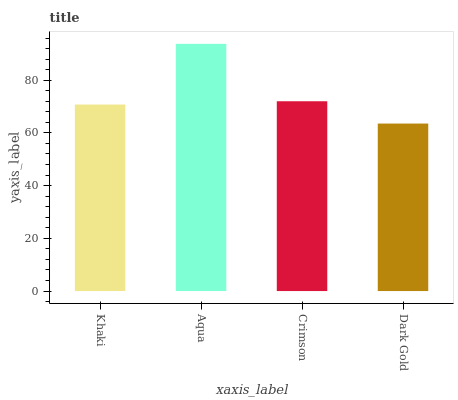Is Dark Gold the minimum?
Answer yes or no. Yes. Is Aqua the maximum?
Answer yes or no. Yes. Is Crimson the minimum?
Answer yes or no. No. Is Crimson the maximum?
Answer yes or no. No. Is Aqua greater than Crimson?
Answer yes or no. Yes. Is Crimson less than Aqua?
Answer yes or no. Yes. Is Crimson greater than Aqua?
Answer yes or no. No. Is Aqua less than Crimson?
Answer yes or no. No. Is Crimson the high median?
Answer yes or no. Yes. Is Khaki the low median?
Answer yes or no. Yes. Is Khaki the high median?
Answer yes or no. No. Is Crimson the low median?
Answer yes or no. No. 